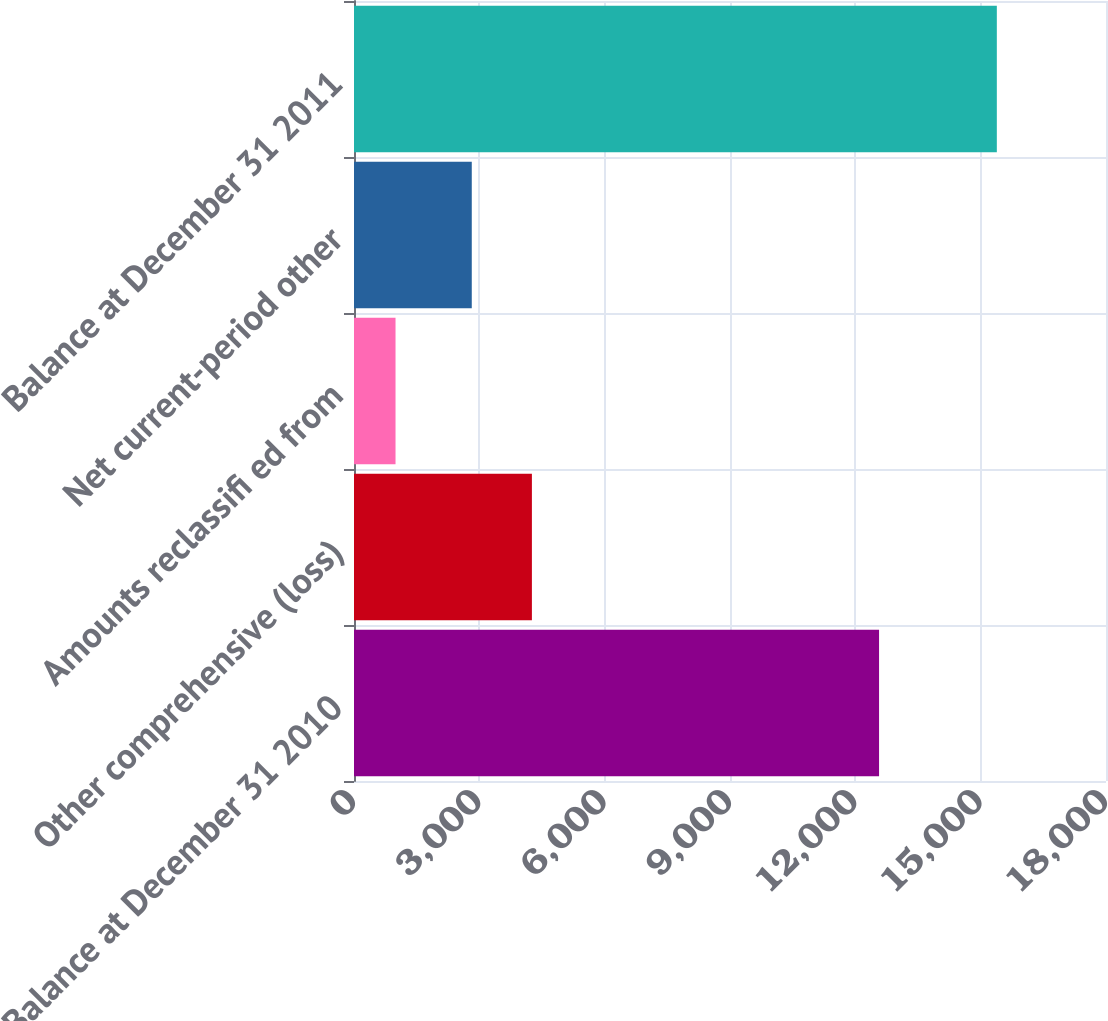Convert chart to OTSL. <chart><loc_0><loc_0><loc_500><loc_500><bar_chart><fcel>Balance at December 31 2010<fcel>Other comprehensive (loss)<fcel>Amounts reclassifi ed from<fcel>Net current-period other<fcel>Balance at December 31 2011<nl><fcel>12568<fcel>4258.3<fcel>994<fcel>2819<fcel>15387<nl></chart> 